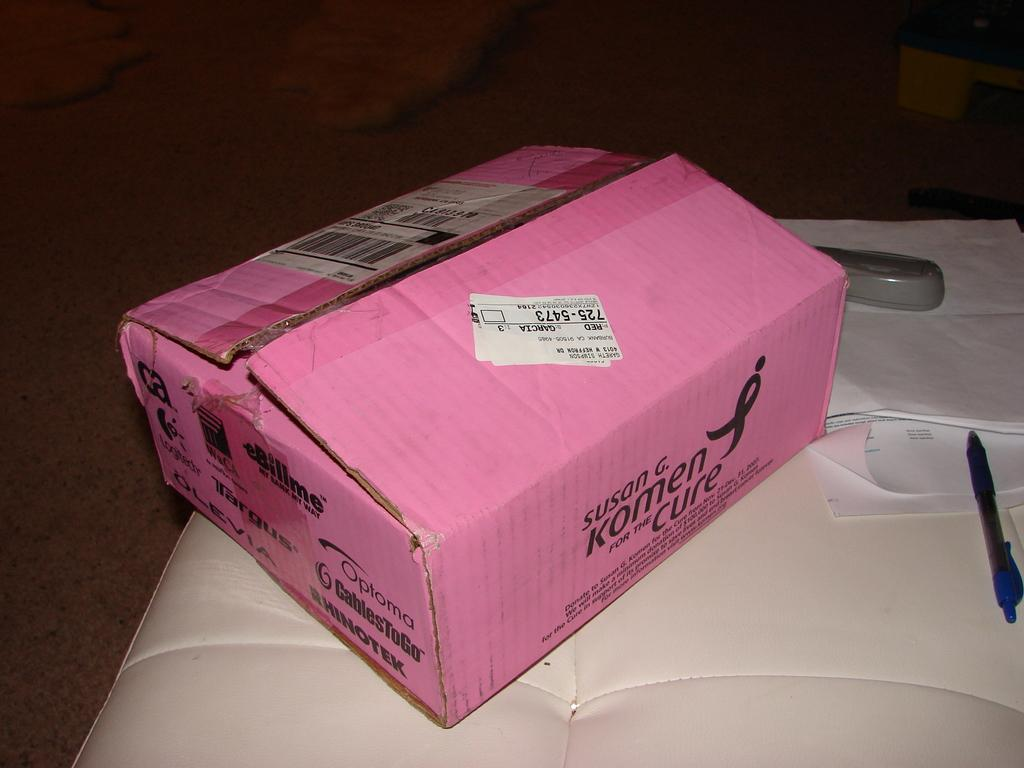<image>
Write a terse but informative summary of the picture. A pink box with the Susan G. Komen breast cancer sign on it. 